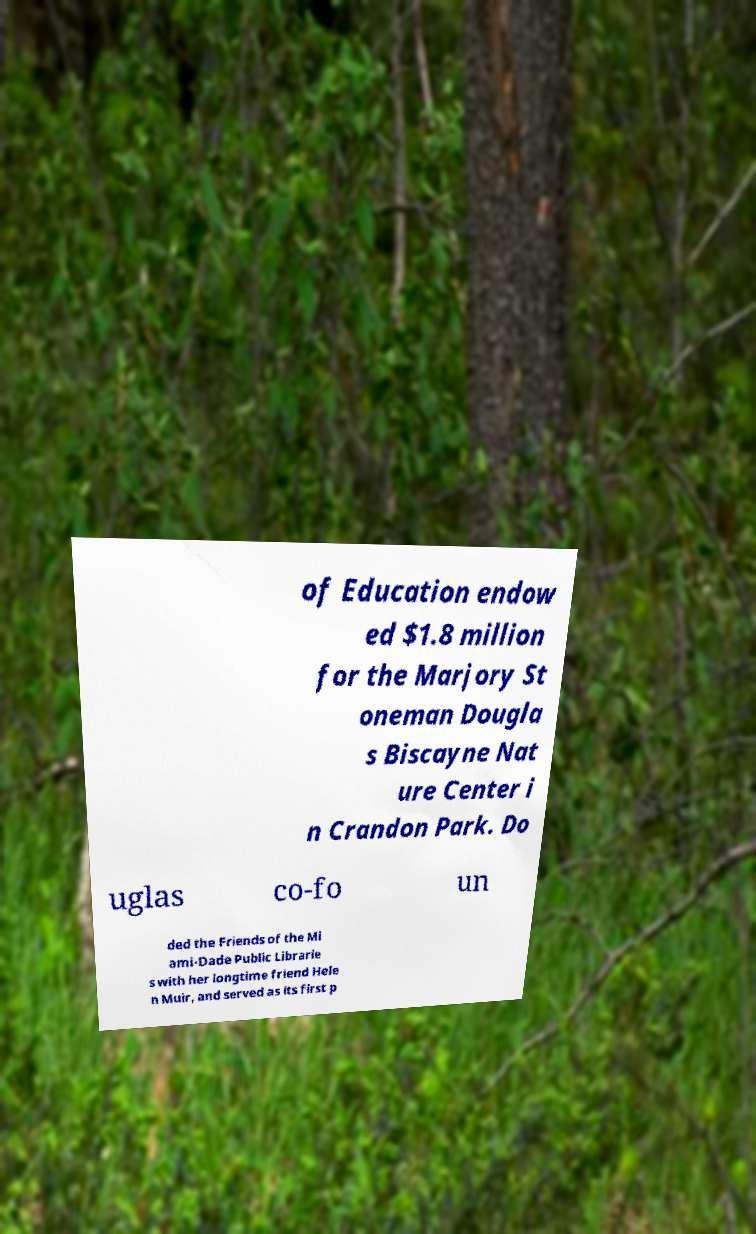For documentation purposes, I need the text within this image transcribed. Could you provide that? of Education endow ed $1.8 million for the Marjory St oneman Dougla s Biscayne Nat ure Center i n Crandon Park. Do uglas co-fo un ded the Friends of the Mi ami-Dade Public Librarie s with her longtime friend Hele n Muir, and served as its first p 